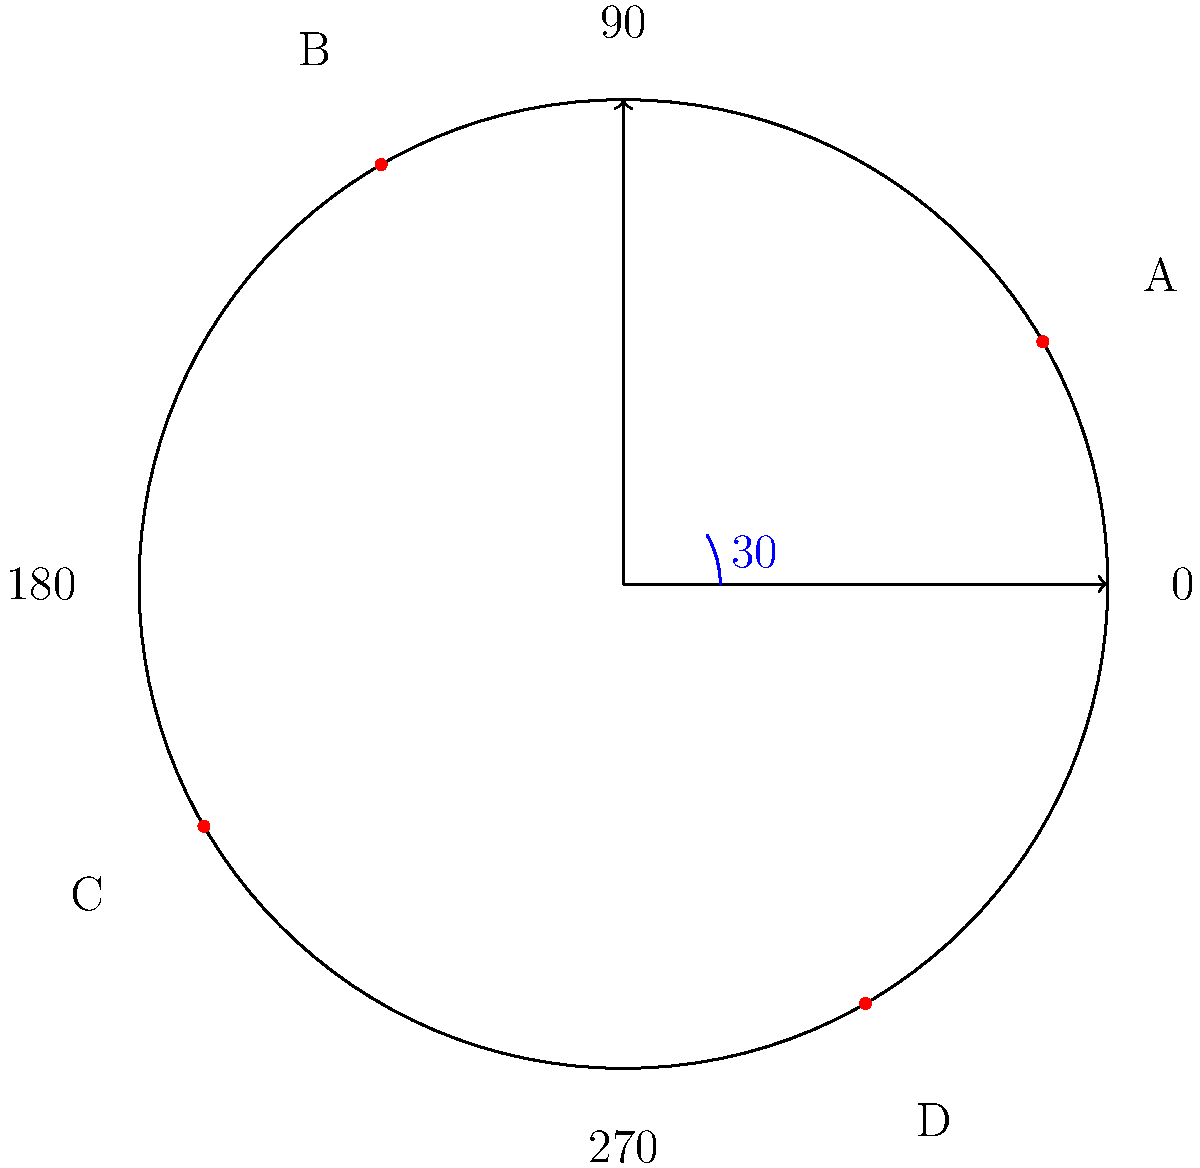In this polar coordinate system, four points (A, B, C, and D) represent the positions of national flags. If point A at $30°$ corresponds to the flag of Ghana, which country's flag is likely represented by point C at $210°$?

a) Brazil
b) Japan
c) Australia
d) South Africa To solve this question, let's follow these steps:

1. Understand the polar coordinate system:
   - The system is divided into 360°
   - 0° is on the positive x-axis, and angles increase counterclockwise

2. Identify the given information:
   - Point A is at 30° and represents Ghana's flag
   - Point C is at 210°

3. Analyze the relationship between points A and C:
   - The difference between their angles is 210° - 30° = 180°
   - This means they are on opposite sides of the circle

4. Consider the geographical relationship:
   - Ghana is in West Africa
   - The country represented by point C should be geographically opposite to Ghana

5. Evaluate the options:
   - Brazil: In South America, not directly opposite to Ghana
   - Japan: In East Asia, not opposite to Ghana
   - Australia: In Oceania, roughly opposite to West Africa
   - South Africa: In Southern Africa, not directly opposite to Ghana

6. Conclude:
   Australia is the most likely answer, as it is geographically opposite to Ghana on a global scale.
Answer: Australia 